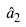<formula> <loc_0><loc_0><loc_500><loc_500>\hat { a } _ { 2 }</formula> 